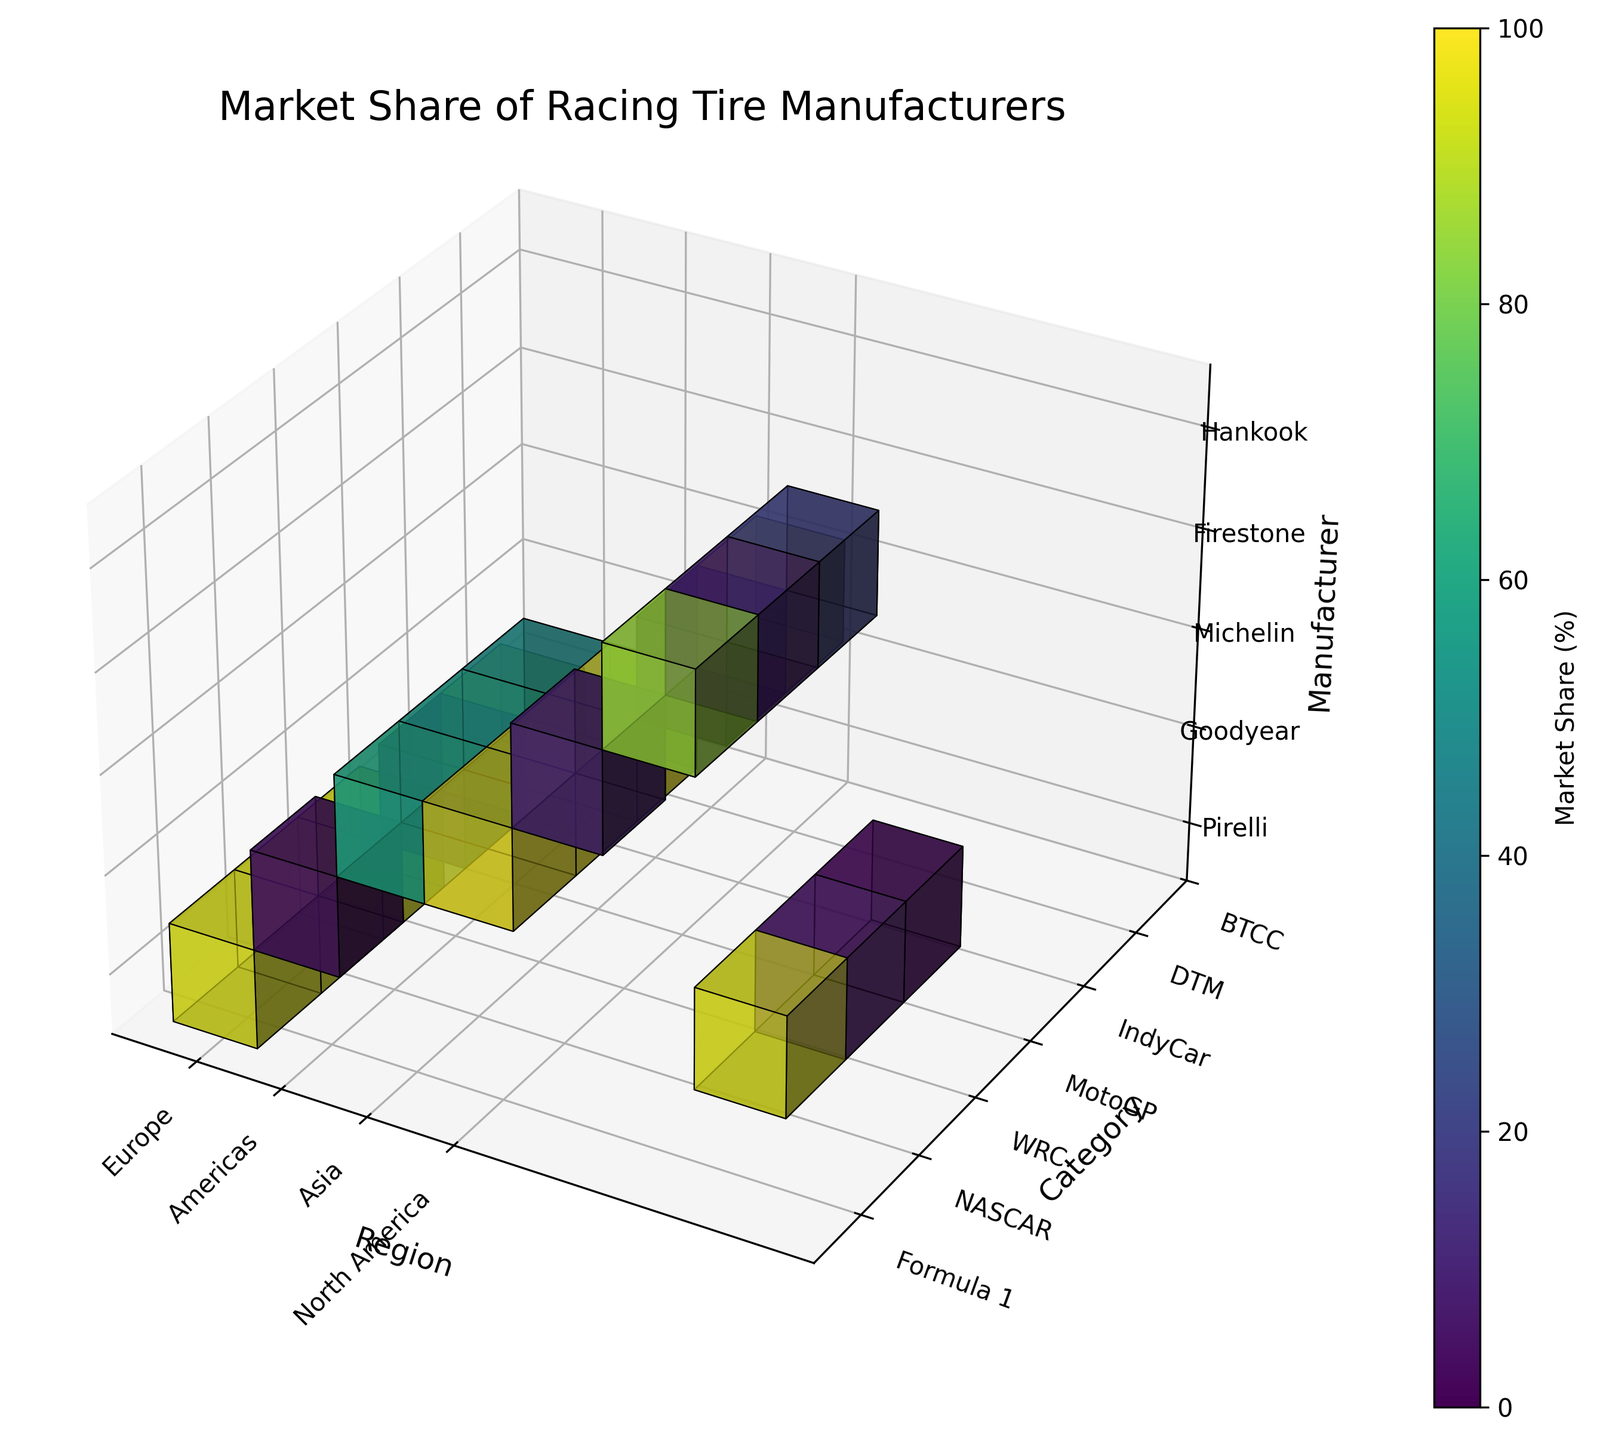Which manufacturer has the highest market share for Formula 1 tires in Europe? The voxel for Formula 1 in Europe is nearly completely filled, and Pirelli is the only manufacturer for this region. Checking the color indicates a high market share close to 100%.
Answer: Pirelli What's the market share of Goodyear in NASCAR in North America? The voxel for NASCAR in North America is mostly filled for Goodyear. Observing the color scale, the share is very high, close to maximum.
Answer: 90% Which motorsport category does Michelin dominate in Asia? Michelin dominates a voxel almost full in the Asia region. Observing the categories, it matches MotoGP, as the color shows close to 100% share.
Answer: MotoGP What is the average market share of Michelin in the regions for the World Rally Championship (WRC)? For Michelin in WRC, Europe has 60%, Americas 55%, and Asia 50%. The average is calculated as (60+55+50) / 3.
Answer: 55% Which category has the most diverse market share across regions? By looking at the varying heights of voxels for each category across regions, DTM appears to have the most variability in market share among regions.
Answer: DTM Compare the market share of Firestone in Europe and Americas for IndyCar. Firestone's voxel for IndyCar is relatively high in the Americas and low in Europe. From the color scale, Americas is near 100%, and Europe is around 10%.
Answer: Americas > Europe What market share does Hankook have in Asia for DTM compared to Europe? The voxel for Hankook in DTM in Asia is filled around a fifth of the height, and in Europe, it’s filled around 85%. The scale shows 20% in Asia vs. 85% in Europe.
Answer: 20% vs. 85% Identify the manufacturer with the least presence (lowest market share) in NASCAR across all regions. Goodyear dominates most of NASCAR's market share, but the low filled heights in Europe and Asia signify the minimum shares.
Answer: Goodyear 